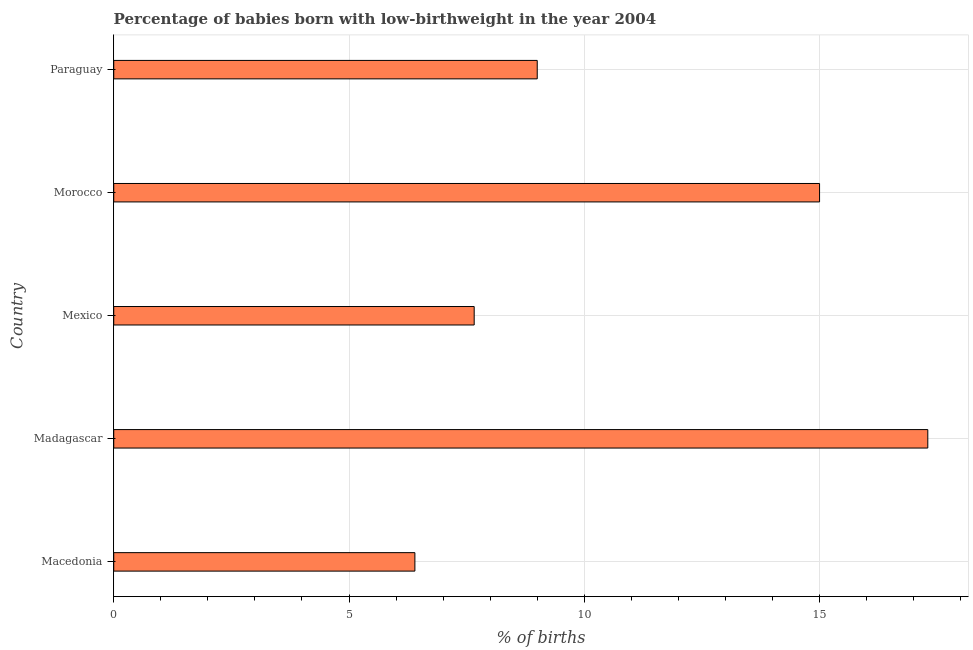Does the graph contain grids?
Ensure brevity in your answer.  Yes. What is the title of the graph?
Provide a succinct answer. Percentage of babies born with low-birthweight in the year 2004. What is the label or title of the X-axis?
Your answer should be compact. % of births. What is the label or title of the Y-axis?
Ensure brevity in your answer.  Country. Across all countries, what is the minimum percentage of babies who were born with low-birthweight?
Offer a very short reply. 6.4. In which country was the percentage of babies who were born with low-birthweight maximum?
Make the answer very short. Madagascar. In which country was the percentage of babies who were born with low-birthweight minimum?
Your answer should be very brief. Macedonia. What is the sum of the percentage of babies who were born with low-birthweight?
Ensure brevity in your answer.  55.36. What is the difference between the percentage of babies who were born with low-birthweight in Madagascar and Morocco?
Provide a succinct answer. 2.3. What is the average percentage of babies who were born with low-birthweight per country?
Provide a short and direct response. 11.07. What is the median percentage of babies who were born with low-birthweight?
Provide a short and direct response. 9. What is the ratio of the percentage of babies who were born with low-birthweight in Mexico to that in Paraguay?
Your answer should be compact. 0.85. Is the difference between the percentage of babies who were born with low-birthweight in Macedonia and Paraguay greater than the difference between any two countries?
Ensure brevity in your answer.  No. Is the sum of the percentage of babies who were born with low-birthweight in Macedonia and Madagascar greater than the maximum percentage of babies who were born with low-birthweight across all countries?
Offer a terse response. Yes. How many bars are there?
Make the answer very short. 5. Are all the bars in the graph horizontal?
Ensure brevity in your answer.  Yes. How many countries are there in the graph?
Provide a succinct answer. 5. What is the % of births of Mexico?
Ensure brevity in your answer.  7.66. What is the % of births in Morocco?
Make the answer very short. 15. What is the difference between the % of births in Macedonia and Mexico?
Offer a terse response. -1.26. What is the difference between the % of births in Madagascar and Mexico?
Your response must be concise. 9.64. What is the difference between the % of births in Madagascar and Morocco?
Make the answer very short. 2.3. What is the difference between the % of births in Mexico and Morocco?
Give a very brief answer. -7.34. What is the difference between the % of births in Mexico and Paraguay?
Ensure brevity in your answer.  -1.34. What is the difference between the % of births in Morocco and Paraguay?
Provide a succinct answer. 6. What is the ratio of the % of births in Macedonia to that in Madagascar?
Keep it short and to the point. 0.37. What is the ratio of the % of births in Macedonia to that in Mexico?
Your answer should be compact. 0.84. What is the ratio of the % of births in Macedonia to that in Morocco?
Your answer should be compact. 0.43. What is the ratio of the % of births in Macedonia to that in Paraguay?
Provide a short and direct response. 0.71. What is the ratio of the % of births in Madagascar to that in Mexico?
Give a very brief answer. 2.26. What is the ratio of the % of births in Madagascar to that in Morocco?
Ensure brevity in your answer.  1.15. What is the ratio of the % of births in Madagascar to that in Paraguay?
Give a very brief answer. 1.92. What is the ratio of the % of births in Mexico to that in Morocco?
Provide a short and direct response. 0.51. What is the ratio of the % of births in Mexico to that in Paraguay?
Ensure brevity in your answer.  0.85. What is the ratio of the % of births in Morocco to that in Paraguay?
Your answer should be compact. 1.67. 